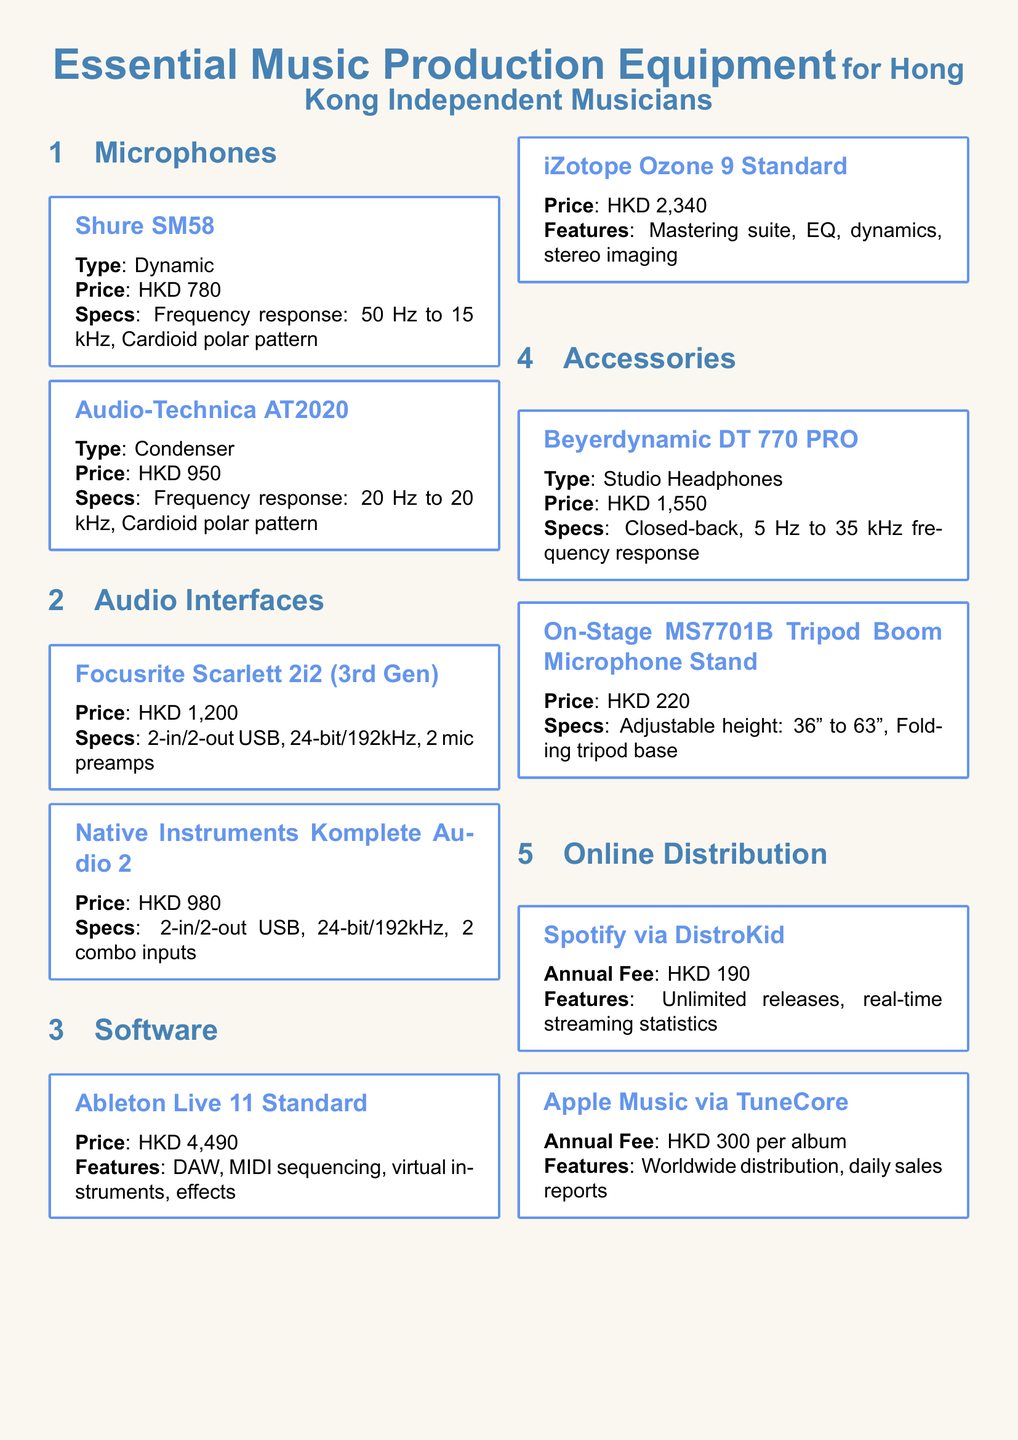What is the price of the Shure SM58? The price of the Shure SM58 microphone is listed in the document as HKD 780.
Answer: HKD 780 What type of microphone is the Audio-Technica AT2020? The document specifies that the Audio-Technica AT2020 is a condenser microphone.
Answer: Condenser What is the price of the Focusrite Scarlett 2i2 (3rd Gen)? The price of the Focusrite Scarlett 2i2 (3rd Gen) audio interface is provided in the document as HKD 1,200.
Answer: HKD 1,200 How many inputs does the Native Instruments Komplete Audio 2 have? The document states that the Native Instruments Komplete Audio 2 has 2 combo inputs.
Answer: 2 combo inputs What are the features of iZotope Ozone 9 Standard? The document lists the features of iZotope Ozone 9 Standard as mastering suite, EQ, dynamics, and stereo imaging.
Answer: Mastering suite, EQ, dynamics, stereo imaging How much does it cost to distribute music on Spotify via DistroKid? The document mentions that the annual fee for distributing music on Spotify via DistroKid is HKD 190.
Answer: HKD 190 What type of headphones are the Beyerdynamic DT 770 PRO? The document categorizes the Beyerdynamic DT 770 PRO as studio headphones.
Answer: Studio Headphones Which microphone stand is listed in the accessories section? The document includes the On-Stage MS7701B Tripod Boom Microphone Stand in the accessories section.
Answer: On-Stage MS7701B Tripod Boom Microphone Stand What is the frequency response range of the Shure SM58? The frequency response range of the Shure SM58 is stated in the document as 50 Hz to 15 kHz.
Answer: 50 Hz to 15 kHz 